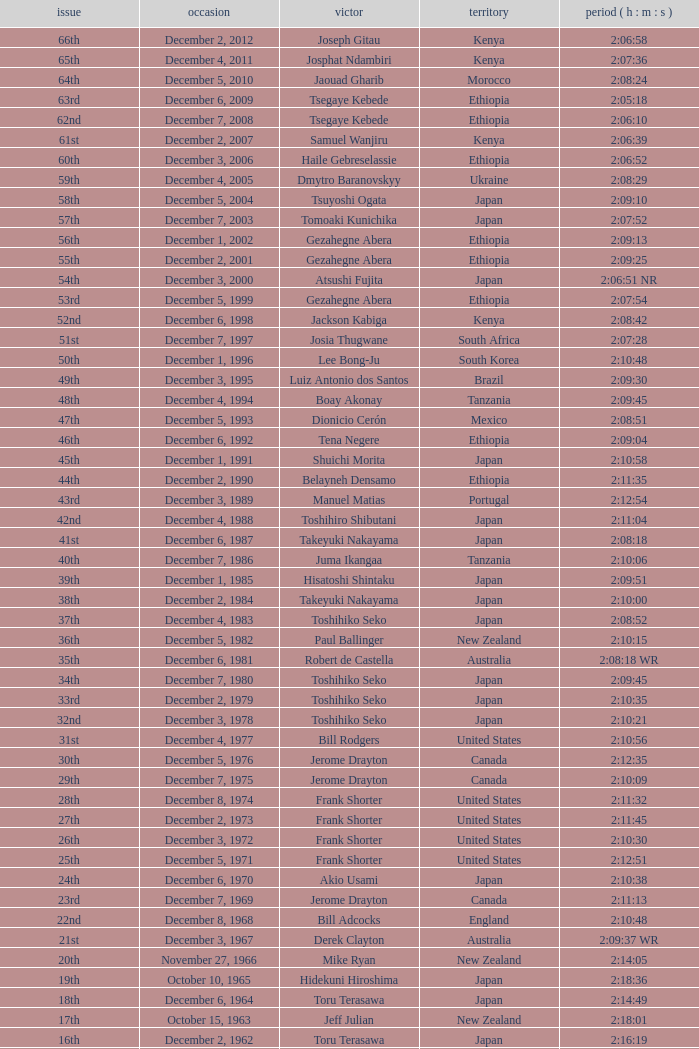Could you parse the entire table as a dict? {'header': ['issue', 'occasion', 'victor', 'territory', 'period ( h : m : s )'], 'rows': [['66th', 'December 2, 2012', 'Joseph Gitau', 'Kenya', '2:06:58'], ['65th', 'December 4, 2011', 'Josphat Ndambiri', 'Kenya', '2:07:36'], ['64th', 'December 5, 2010', 'Jaouad Gharib', 'Morocco', '2:08:24'], ['63rd', 'December 6, 2009', 'Tsegaye Kebede', 'Ethiopia', '2:05:18'], ['62nd', 'December 7, 2008', 'Tsegaye Kebede', 'Ethiopia', '2:06:10'], ['61st', 'December 2, 2007', 'Samuel Wanjiru', 'Kenya', '2:06:39'], ['60th', 'December 3, 2006', 'Haile Gebreselassie', 'Ethiopia', '2:06:52'], ['59th', 'December 4, 2005', 'Dmytro Baranovskyy', 'Ukraine', '2:08:29'], ['58th', 'December 5, 2004', 'Tsuyoshi Ogata', 'Japan', '2:09:10'], ['57th', 'December 7, 2003', 'Tomoaki Kunichika', 'Japan', '2:07:52'], ['56th', 'December 1, 2002', 'Gezahegne Abera', 'Ethiopia', '2:09:13'], ['55th', 'December 2, 2001', 'Gezahegne Abera', 'Ethiopia', '2:09:25'], ['54th', 'December 3, 2000', 'Atsushi Fujita', 'Japan', '2:06:51 NR'], ['53rd', 'December 5, 1999', 'Gezahegne Abera', 'Ethiopia', '2:07:54'], ['52nd', 'December 6, 1998', 'Jackson Kabiga', 'Kenya', '2:08:42'], ['51st', 'December 7, 1997', 'Josia Thugwane', 'South Africa', '2:07:28'], ['50th', 'December 1, 1996', 'Lee Bong-Ju', 'South Korea', '2:10:48'], ['49th', 'December 3, 1995', 'Luiz Antonio dos Santos', 'Brazil', '2:09:30'], ['48th', 'December 4, 1994', 'Boay Akonay', 'Tanzania', '2:09:45'], ['47th', 'December 5, 1993', 'Dionicio Cerón', 'Mexico', '2:08:51'], ['46th', 'December 6, 1992', 'Tena Negere', 'Ethiopia', '2:09:04'], ['45th', 'December 1, 1991', 'Shuichi Morita', 'Japan', '2:10:58'], ['44th', 'December 2, 1990', 'Belayneh Densamo', 'Ethiopia', '2:11:35'], ['43rd', 'December 3, 1989', 'Manuel Matias', 'Portugal', '2:12:54'], ['42nd', 'December 4, 1988', 'Toshihiro Shibutani', 'Japan', '2:11:04'], ['41st', 'December 6, 1987', 'Takeyuki Nakayama', 'Japan', '2:08:18'], ['40th', 'December 7, 1986', 'Juma Ikangaa', 'Tanzania', '2:10:06'], ['39th', 'December 1, 1985', 'Hisatoshi Shintaku', 'Japan', '2:09:51'], ['38th', 'December 2, 1984', 'Takeyuki Nakayama', 'Japan', '2:10:00'], ['37th', 'December 4, 1983', 'Toshihiko Seko', 'Japan', '2:08:52'], ['36th', 'December 5, 1982', 'Paul Ballinger', 'New Zealand', '2:10:15'], ['35th', 'December 6, 1981', 'Robert de Castella', 'Australia', '2:08:18 WR'], ['34th', 'December 7, 1980', 'Toshihiko Seko', 'Japan', '2:09:45'], ['33rd', 'December 2, 1979', 'Toshihiko Seko', 'Japan', '2:10:35'], ['32nd', 'December 3, 1978', 'Toshihiko Seko', 'Japan', '2:10:21'], ['31st', 'December 4, 1977', 'Bill Rodgers', 'United States', '2:10:56'], ['30th', 'December 5, 1976', 'Jerome Drayton', 'Canada', '2:12:35'], ['29th', 'December 7, 1975', 'Jerome Drayton', 'Canada', '2:10:09'], ['28th', 'December 8, 1974', 'Frank Shorter', 'United States', '2:11:32'], ['27th', 'December 2, 1973', 'Frank Shorter', 'United States', '2:11:45'], ['26th', 'December 3, 1972', 'Frank Shorter', 'United States', '2:10:30'], ['25th', 'December 5, 1971', 'Frank Shorter', 'United States', '2:12:51'], ['24th', 'December 6, 1970', 'Akio Usami', 'Japan', '2:10:38'], ['23rd', 'December 7, 1969', 'Jerome Drayton', 'Canada', '2:11:13'], ['22nd', 'December 8, 1968', 'Bill Adcocks', 'England', '2:10:48'], ['21st', 'December 3, 1967', 'Derek Clayton', 'Australia', '2:09:37 WR'], ['20th', 'November 27, 1966', 'Mike Ryan', 'New Zealand', '2:14:05'], ['19th', 'October 10, 1965', 'Hidekuni Hiroshima', 'Japan', '2:18:36'], ['18th', 'December 6, 1964', 'Toru Terasawa', 'Japan', '2:14:49'], ['17th', 'October 15, 1963', 'Jeff Julian', 'New Zealand', '2:18:01'], ['16th', 'December 2, 1962', 'Toru Terasawa', 'Japan', '2:16:19'], ['15th', 'December 3, 1961', 'Pavel Kantorek', 'Czech Republic', '2:22:05'], ['14th', 'December 4, 1960', 'Barry Magee', 'New Zealand', '2:19:04'], ['13th', 'November 8, 1959', 'Kurao Hiroshima', 'Japan', '2:29:34'], ['12th', 'December 7, 1958', 'Nobuyoshi Sadanaga', 'Japan', '2:24:01'], ['11th', 'December 1, 1957', 'Kurao Hiroshima', 'Japan', '2:21:40'], ['10th', 'December 9, 1956', 'Keizo Yamada', 'Japan', '2:25:15'], ['9th', 'December 11, 1955', 'Veikko Karvonen', 'Finland', '2:23:16'], ['8th', 'December 5, 1954', 'Reinaldo Gorno', 'Argentina', '2:24:55'], ['7th', 'December 6, 1953', 'Hideo Hamamura', 'Japan', '2:27:26'], ['6th', 'December 7, 1952', 'Katsuo Nishida', 'Japan', '2:27:59'], ['5th', 'December 9, 1951', 'Hiromi Haigo', 'Japan', '2:30:13'], ['4th', 'December 10, 1950', 'Shunji Koyanagi', 'Japan', '2:30:47'], ['3rd', 'December 4, 1949', 'Shinzo Koga', 'Japan', '2:40:26'], ['2nd', 'December 5, 1948', 'Saburo Yamada', 'Japan', '2:37:25'], ['1st', 'December 7, 1947', 'Toshikazu Wada', 'Japan', '2:45:45']]} Who was the winner of the 23rd Edition? Jerome Drayton. 